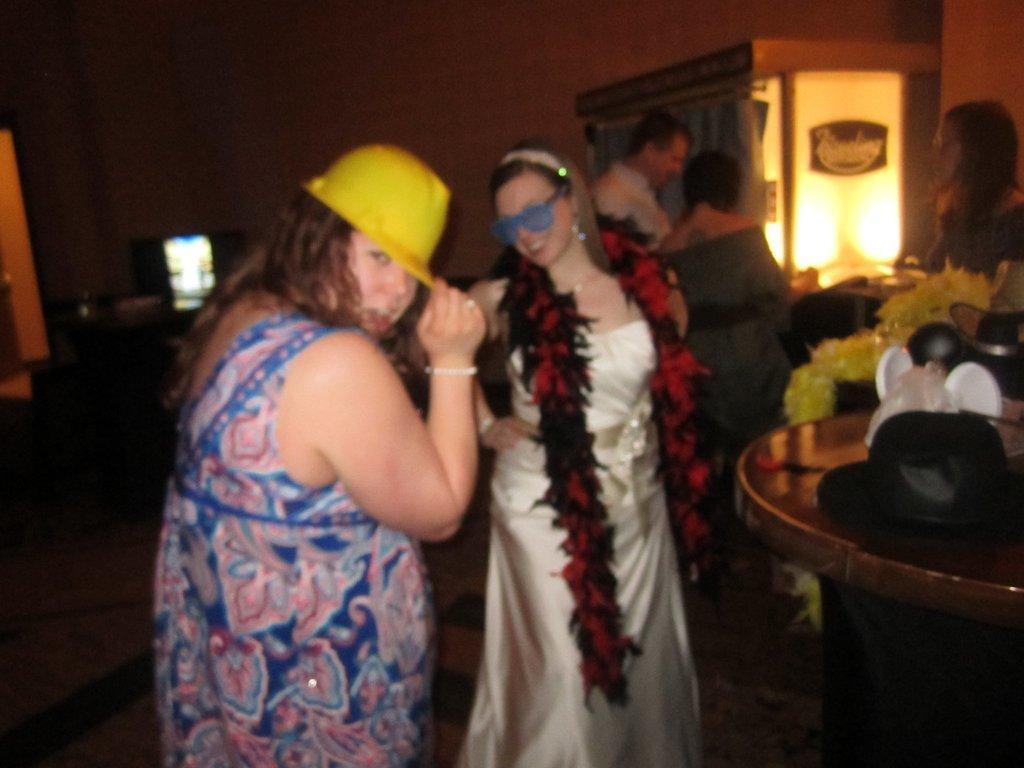How many people are present in the image? There are two women and three men in the image, making a total of five people. What are the women doing in the image? The women are dancing in the image. What are the men doing in the image? The men are standing in the image. What type of order can be seen in the drawer in the image? There is no drawer present in the image, so it is not possible to determine the order of anything inside a drawer. 